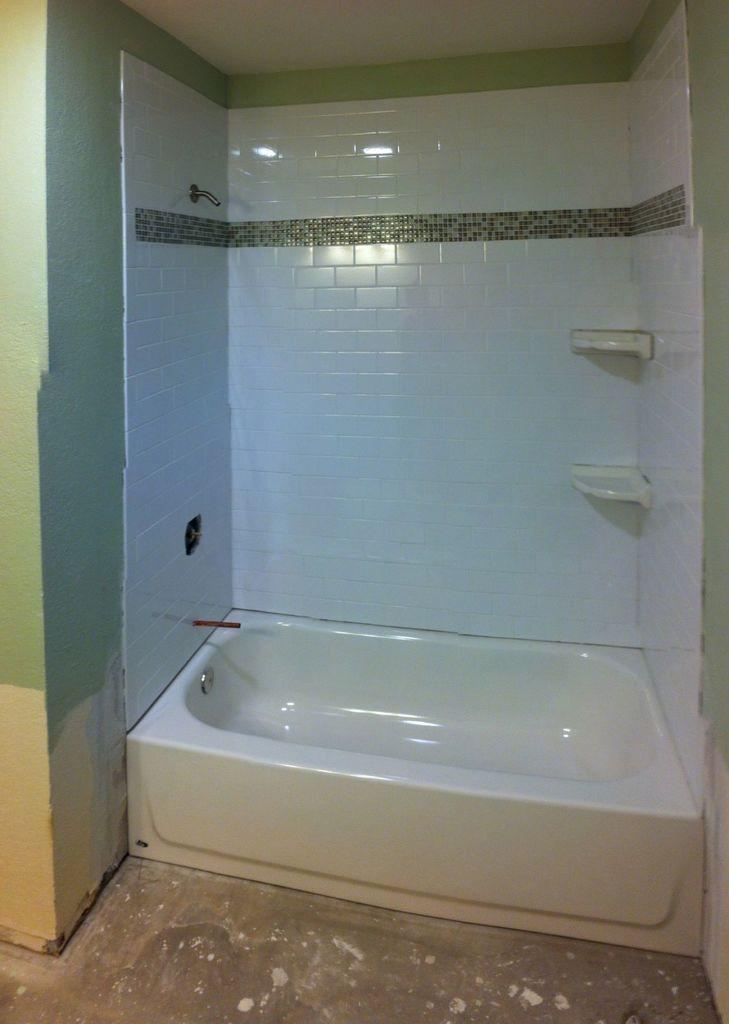Please provide a concise description of this image. In this picture we can see a bathtub, wall, tiles, soap holders and objects. At the bottom portion of the picture we can see the floor. 